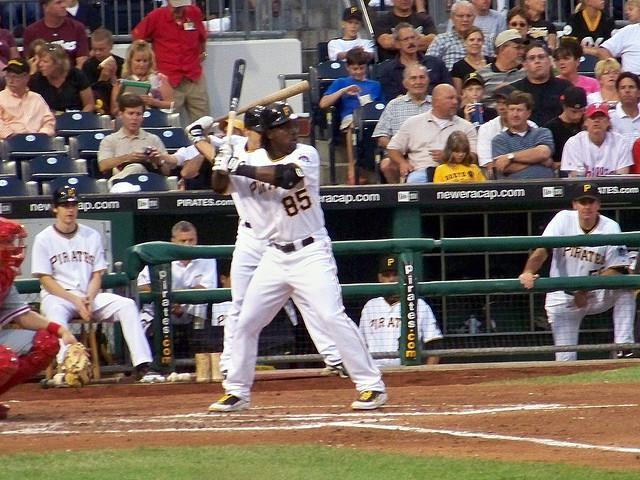How many people are there?
Give a very brief answer. 12. 